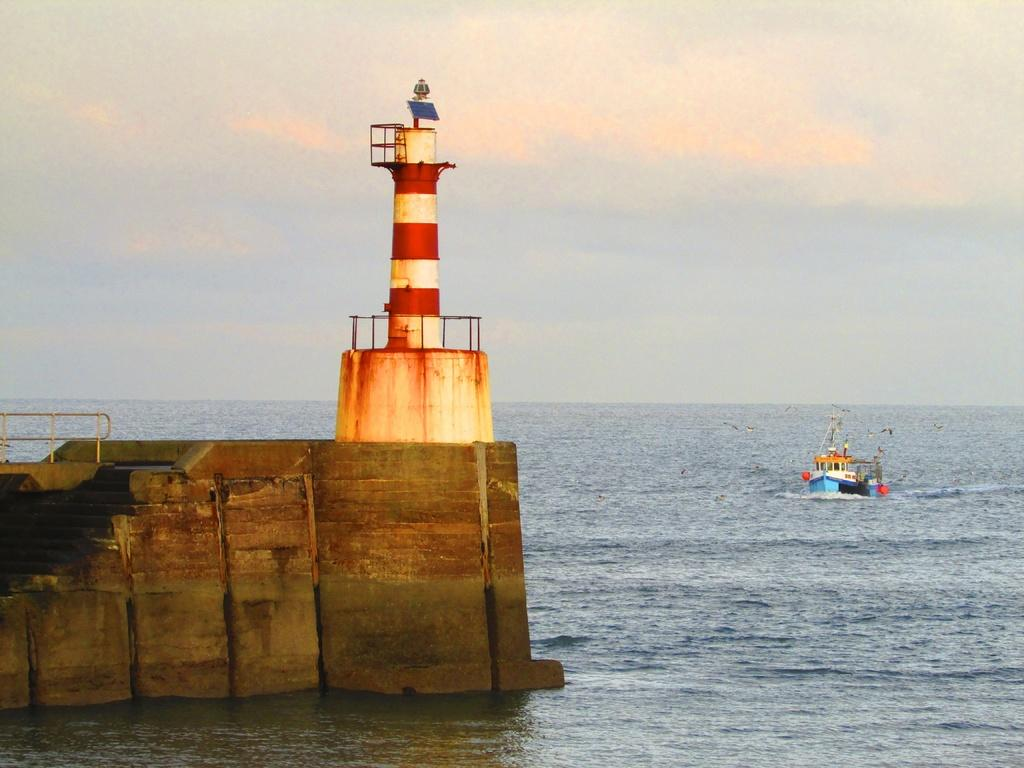What structure is the main subject of the image? There is a lighthouse in the image. What can be seen near the lighthouse? There are stairs in the image. What is present in the water in the image? There is a boat in the water in the image. How would you describe the sky in the image? The sky is cloudy in the image. Can you see a rabbit hopping near the lighthouse in the image? No, there is no rabbit present in the image. 